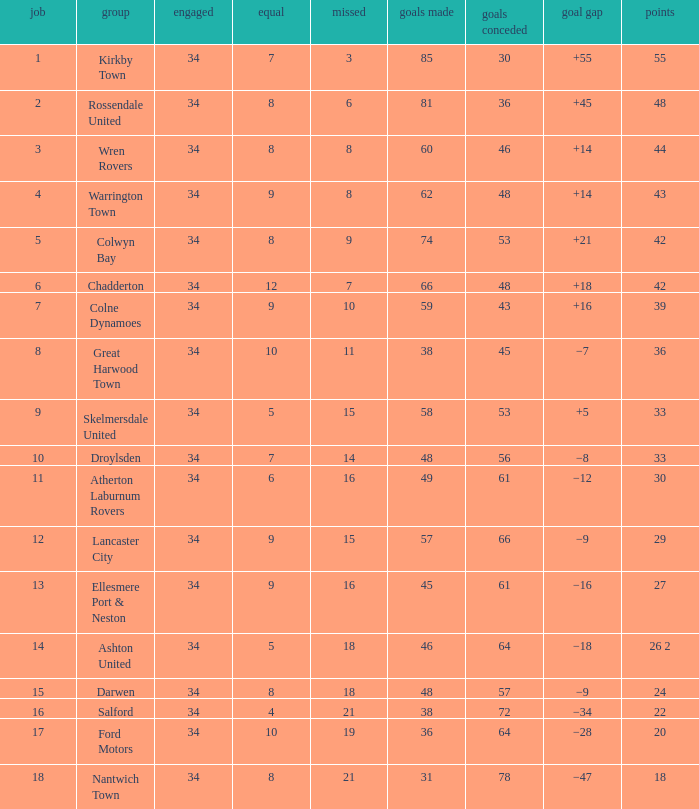What is the total number of goals for when the drawn is less than 7, less than 21 games have been lost, and there are 1 of 33 points? 1.0. 